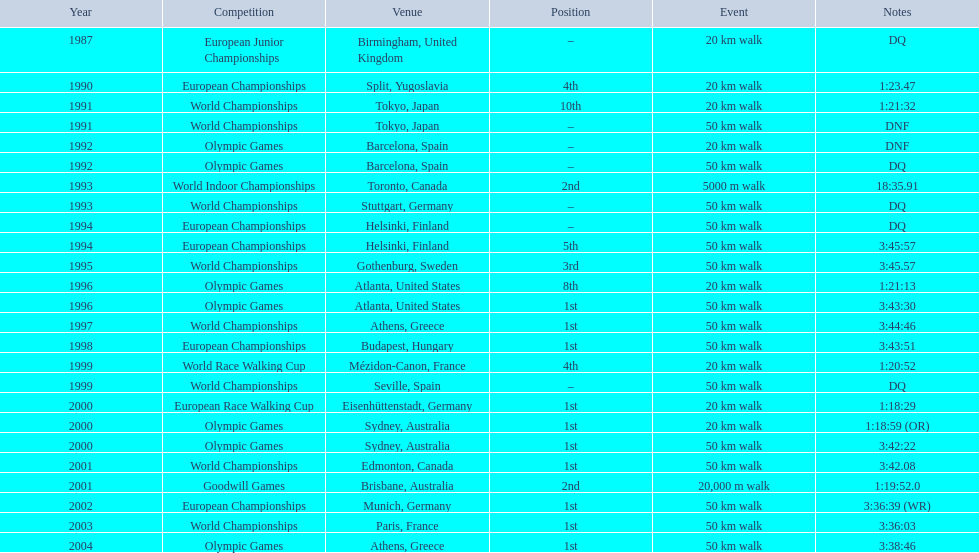What was the difference between korzeniowski's performance at the 1996 olympic games and the 2000 olympic games in the 20 km walk? 2:14. 